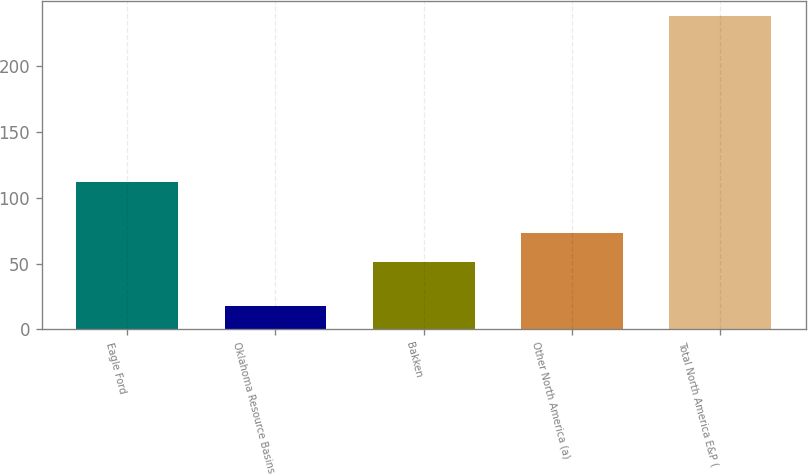<chart> <loc_0><loc_0><loc_500><loc_500><bar_chart><fcel>Eagle Ford<fcel>Oklahoma Resource Basins<fcel>Bakken<fcel>Other North America (a)<fcel>Total North America E&P (<nl><fcel>112<fcel>18<fcel>51<fcel>73<fcel>238<nl></chart> 